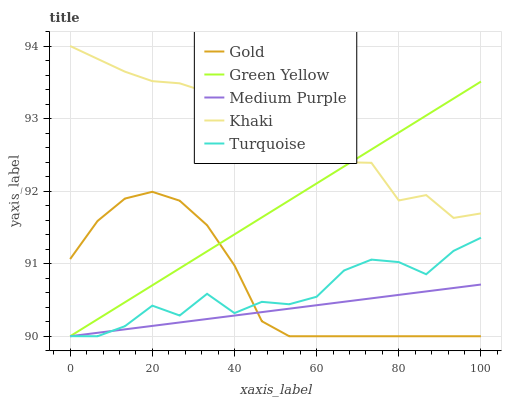Does Medium Purple have the minimum area under the curve?
Answer yes or no. Yes. Does Khaki have the maximum area under the curve?
Answer yes or no. Yes. Does Turquoise have the minimum area under the curve?
Answer yes or no. No. Does Turquoise have the maximum area under the curve?
Answer yes or no. No. Is Medium Purple the smoothest?
Answer yes or no. Yes. Is Turquoise the roughest?
Answer yes or no. Yes. Is Green Yellow the smoothest?
Answer yes or no. No. Is Green Yellow the roughest?
Answer yes or no. No. Does Medium Purple have the lowest value?
Answer yes or no. Yes. Does Khaki have the lowest value?
Answer yes or no. No. Does Khaki have the highest value?
Answer yes or no. Yes. Does Turquoise have the highest value?
Answer yes or no. No. Is Gold less than Khaki?
Answer yes or no. Yes. Is Khaki greater than Turquoise?
Answer yes or no. Yes. Does Gold intersect Medium Purple?
Answer yes or no. Yes. Is Gold less than Medium Purple?
Answer yes or no. No. Is Gold greater than Medium Purple?
Answer yes or no. No. Does Gold intersect Khaki?
Answer yes or no. No. 